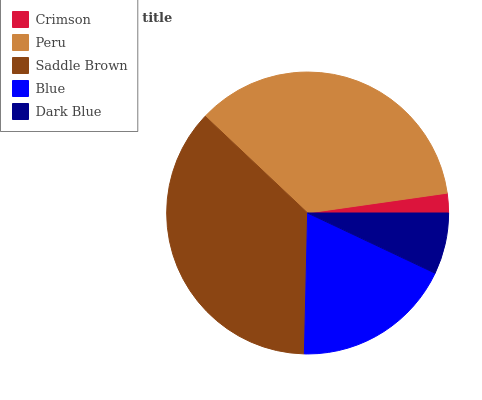Is Crimson the minimum?
Answer yes or no. Yes. Is Saddle Brown the maximum?
Answer yes or no. Yes. Is Peru the minimum?
Answer yes or no. No. Is Peru the maximum?
Answer yes or no. No. Is Peru greater than Crimson?
Answer yes or no. Yes. Is Crimson less than Peru?
Answer yes or no. Yes. Is Crimson greater than Peru?
Answer yes or no. No. Is Peru less than Crimson?
Answer yes or no. No. Is Blue the high median?
Answer yes or no. Yes. Is Blue the low median?
Answer yes or no. Yes. Is Saddle Brown the high median?
Answer yes or no. No. Is Peru the low median?
Answer yes or no. No. 